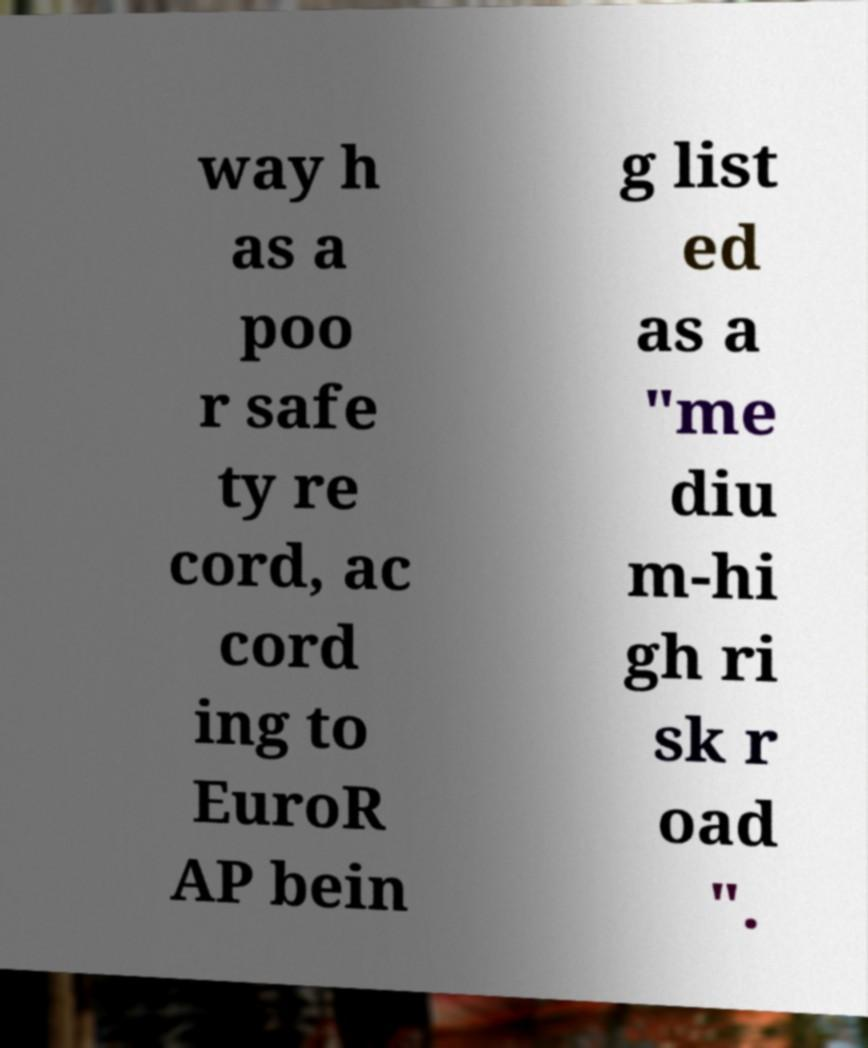Please read and relay the text visible in this image. What does it say? way h as a poo r safe ty re cord, ac cord ing to EuroR AP bein g list ed as a "me diu m-hi gh ri sk r oad ". 